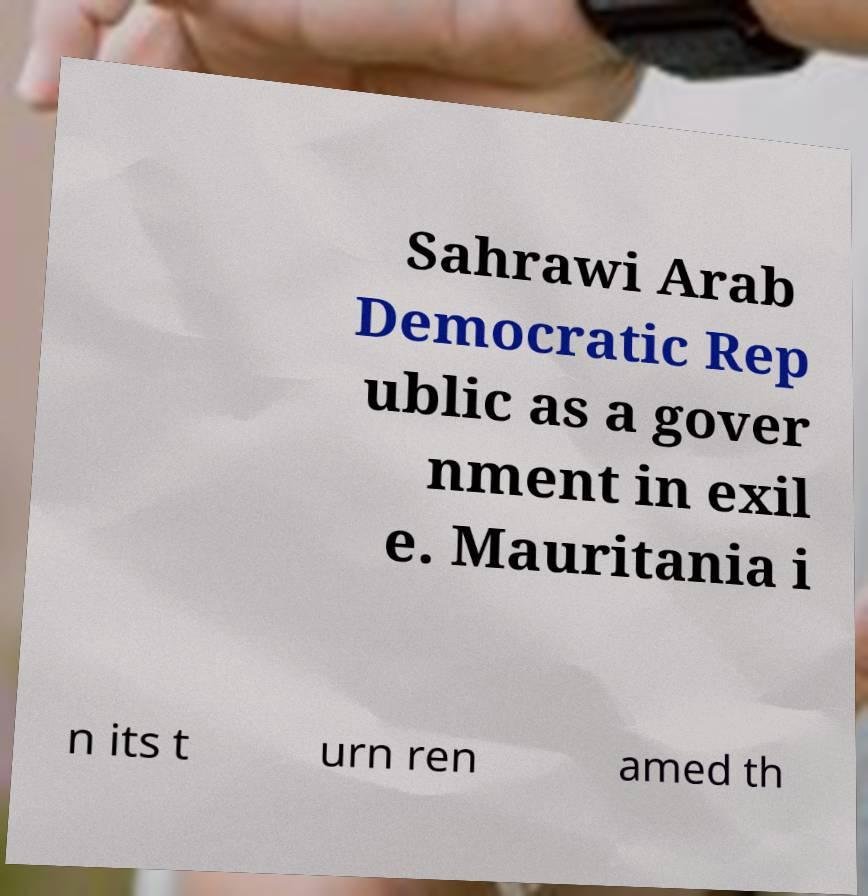What messages or text are displayed in this image? I need them in a readable, typed format. Sahrawi Arab Democratic Rep ublic as a gover nment in exil e. Mauritania i n its t urn ren amed th 